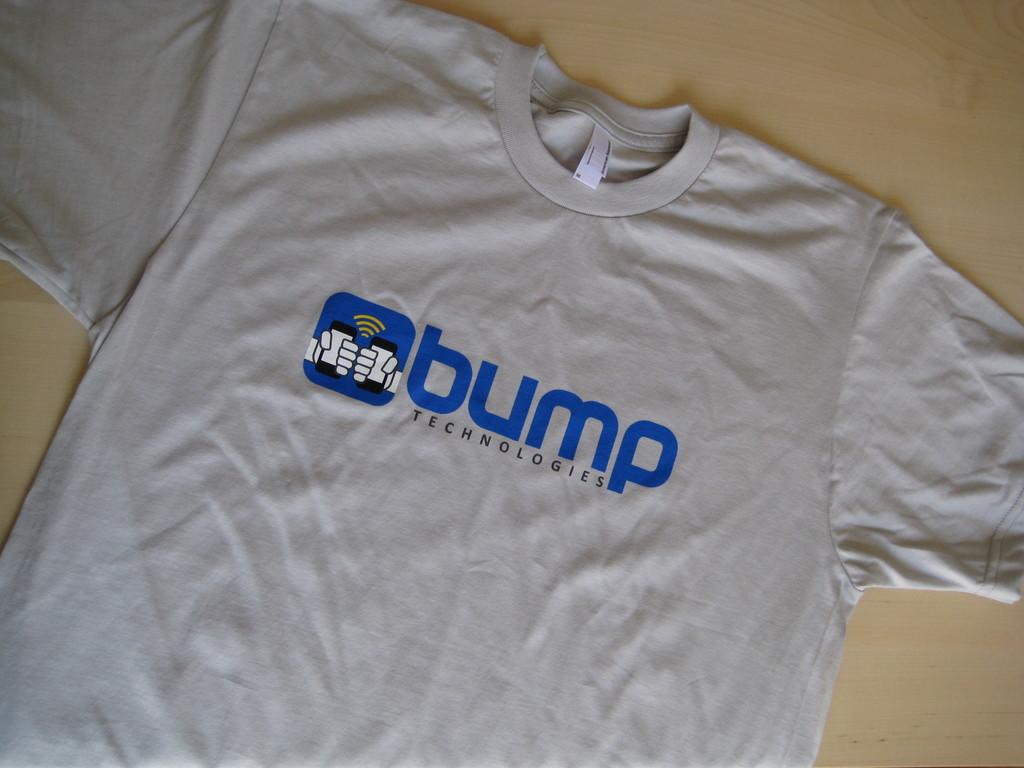Provide a one-sentence caption for the provided image. A grey tshirt with the word Bump on it. 